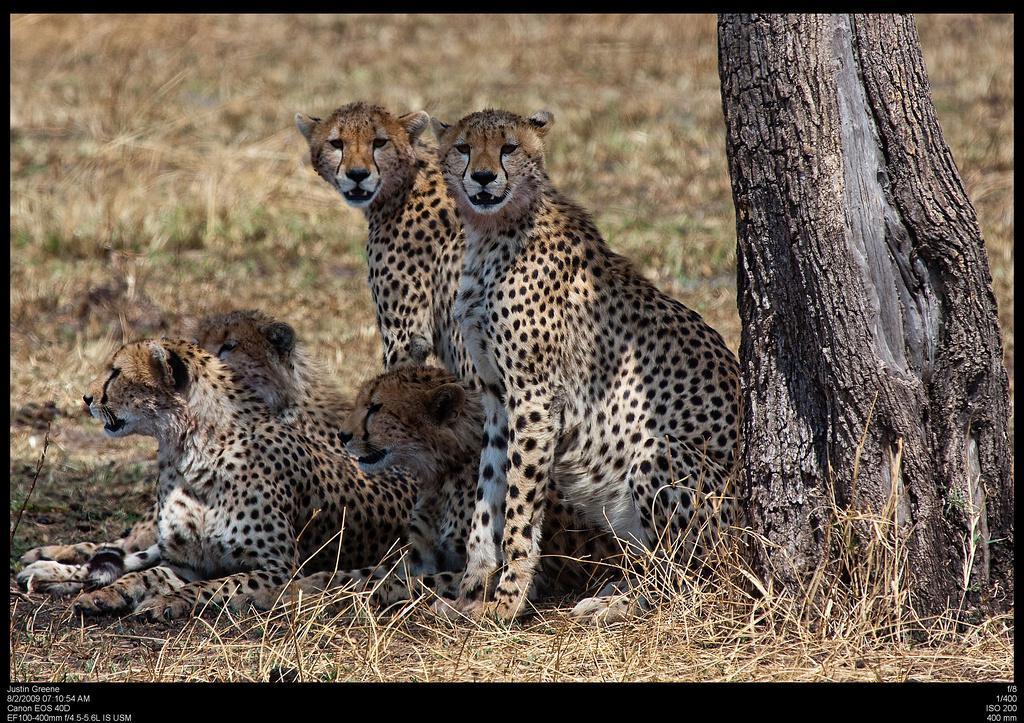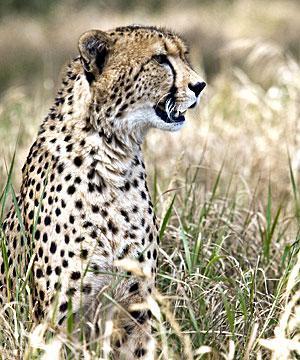The first image is the image on the left, the second image is the image on the right. Analyze the images presented: Is the assertion "The image on the right has one lone cheetah sitting in the grass." valid? Answer yes or no. Yes. 